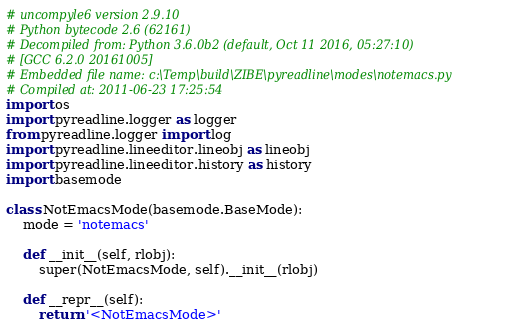Convert code to text. <code><loc_0><loc_0><loc_500><loc_500><_Python_># uncompyle6 version 2.9.10
# Python bytecode 2.6 (62161)
# Decompiled from: Python 3.6.0b2 (default, Oct 11 2016, 05:27:10) 
# [GCC 6.2.0 20161005]
# Embedded file name: c:\Temp\build\ZIBE\pyreadline\modes\notemacs.py
# Compiled at: 2011-06-23 17:25:54
import os
import pyreadline.logger as logger
from pyreadline.logger import log
import pyreadline.lineeditor.lineobj as lineobj
import pyreadline.lineeditor.history as history
import basemode

class NotEmacsMode(basemode.BaseMode):
    mode = 'notemacs'

    def __init__(self, rlobj):
        super(NotEmacsMode, self).__init__(rlobj)

    def __repr__(self):
        return '<NotEmacsMode>'
</code> 